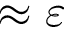Convert formula to latex. <formula><loc_0><loc_0><loc_500><loc_500>\approx \varepsilon</formula> 